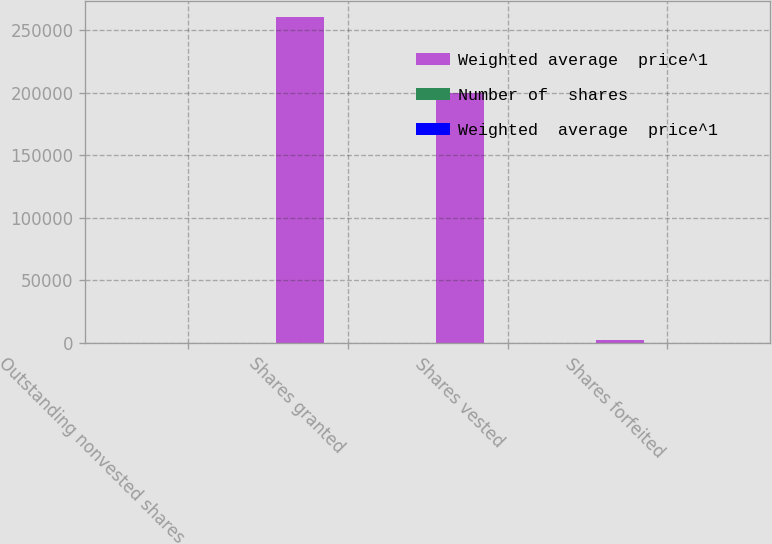Convert chart. <chart><loc_0><loc_0><loc_500><loc_500><stacked_bar_chart><ecel><fcel>Outstanding nonvested shares<fcel>Shares granted<fcel>Shares vested<fcel>Shares forfeited<nl><fcel>Weighted average  price^1<fcel>48.15<fcel>260171<fcel>200066<fcel>2864<nl><fcel>Number of  shares<fcel>48.33<fcel>54.14<fcel>43.26<fcel>48.15<nl><fcel>Weighted  average  price^1<fcel>30.46<fcel>50.87<fcel>37.7<fcel>45.58<nl></chart> 